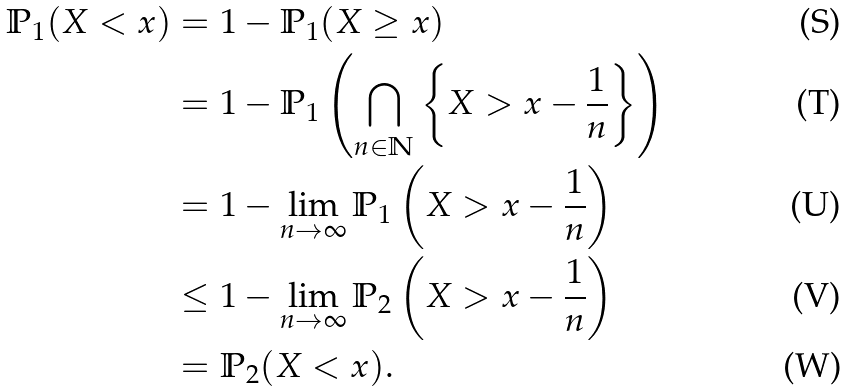<formula> <loc_0><loc_0><loc_500><loc_500>\mathbb { P } _ { 1 } ( X < x ) & = 1 - \mathbb { P } _ { 1 } ( X \geq x ) \\ & = 1 - \mathbb { P } _ { 1 } \left ( \bigcap _ { n \in \mathbb { N } } \left \{ X > x - \frac { 1 } { n } \right \} \right ) \\ & = 1 - \lim _ { n \rightarrow \infty } \mathbb { P } _ { 1 } \left ( X > x - \frac { 1 } { n } \right ) \\ & \leq 1 - \lim _ { n \rightarrow \infty } \mathbb { P } _ { 2 } \left ( X > x - \frac { 1 } { n } \right ) \\ & = \mathbb { P } _ { 2 } ( X < x ) .</formula> 